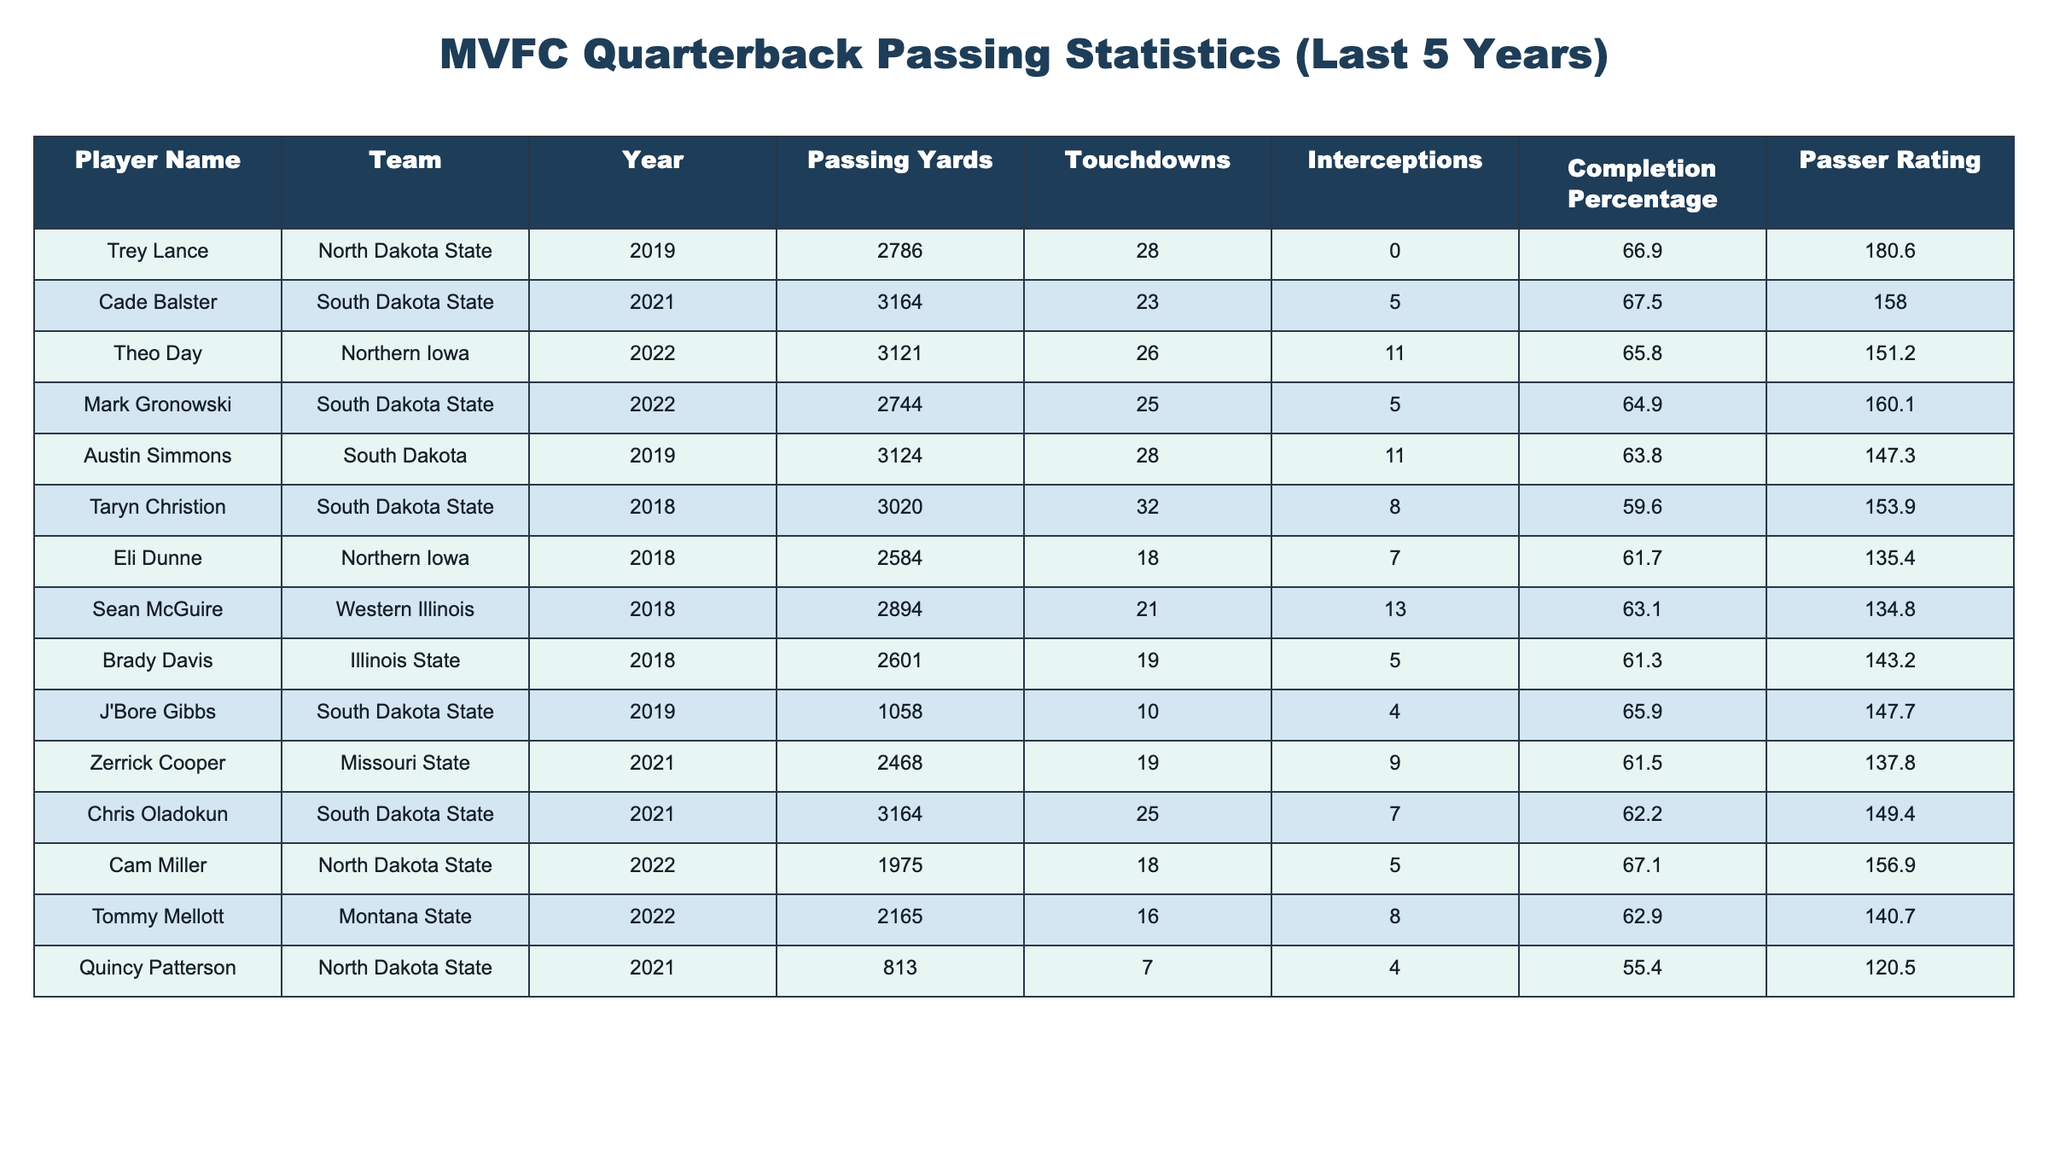What is the total number of touchdowns scored by all players in 2021? In 2021, Cade Balster scored 23 touchdowns, Zerrick Cooper scored 19 touchdowns, Chris Oladokun scored 25 touchdowns, and Quincy Patterson scored 7 touchdowns. Adding these gives us 23 + 19 + 25 + 7 = 74 touchdowns.
Answer: 74 Which player had the highest passer rating in the table? The passer ratings listed are: Trey Lance 180.6, Cade Balster 158.0, Theo Day 151.2, Mark Gronowski 160.1, Austin Simmons 147.3, Taryn Christion 153.9, Eli Dunne 135.4, Sean McGuire 134.8, Brady Davis 143.2, J'Bore Gibbs 147.7, Zerrick Cooper 137.8, Chris Oladokun 149.4, Cam Miller 156.9, Tommy Mellott 140.7, and Quincy Patterson 120.5. The highest is Trey Lance with a rating of 180.6.
Answer: Trey Lance What is the average completion percentage of the quarterbacks in 2019? The completion percentages for 2019 are: Trey Lance 66.9% and Austin Simmons 63.8%. To find the average, add 66.9 and 63.8 to get 130.7, then divide by 2, yielding an average of 65.35%.
Answer: 65.35% Did any player throw more than 30 touchdowns in a single year? Looking through the touchdowns per year, we see Taryn Christion with 32 touchdowns in 2018, which is more than 30. Therefore, the answer is yes.
Answer: Yes Which year had the most passing yards from the players in the table? The passing yards by year are: 2018 has 3020 (Taryn Christion), 2019 has 2786 (Trey Lance) and 3124 (Austin Simmons), 2021 has 3164 (Cade Balster and Chris Oladokun), and 2022 has 3121 (Theo Day). 2021 has the highest total with 3164 yards.
Answer: 2021 What is the difference between the highest and lowest completion percentage in the table? The highest completion percentage is 67.5% from Cade Balster, and the lowest is 55.4% from Quincy Patterson. The difference is 67.5 - 55.4 = 12.1%.
Answer: 12.1% Which team had the most notable quarterback in terms of passing yards in 2022? In 2022, the notable quarterbcks were Theo Day with 3121 yards and Mark Gronowski with 2744 yards from South Dakota State. The highest passing yardage is from Theo Day of Northern Iowa with 3121 yards.
Answer: Northern Iowa Based on the passing statistics, did South Dakota State have the highest scoring quarterback in terms of touchdown passes in 2018? In 2018, Taryn Christion from South Dakota State had 32 touchdowns which is the highest compared to others in that year. Thus, South Dakota State had the highest scoring quarterback in 2018.
Answer: Yes How many quarterbacks threw more than 20 touchdowns in 2022? In 2022, Theo Day threw 26 touchdowns, Mark Gronowski threw 25 touchdowns, and Cam Miller threw 18 touchdowns. Therefore, only two quarterbacks threw more than 20 touchdowns which are Theo Day and Mark Gronowski.
Answer: 2 